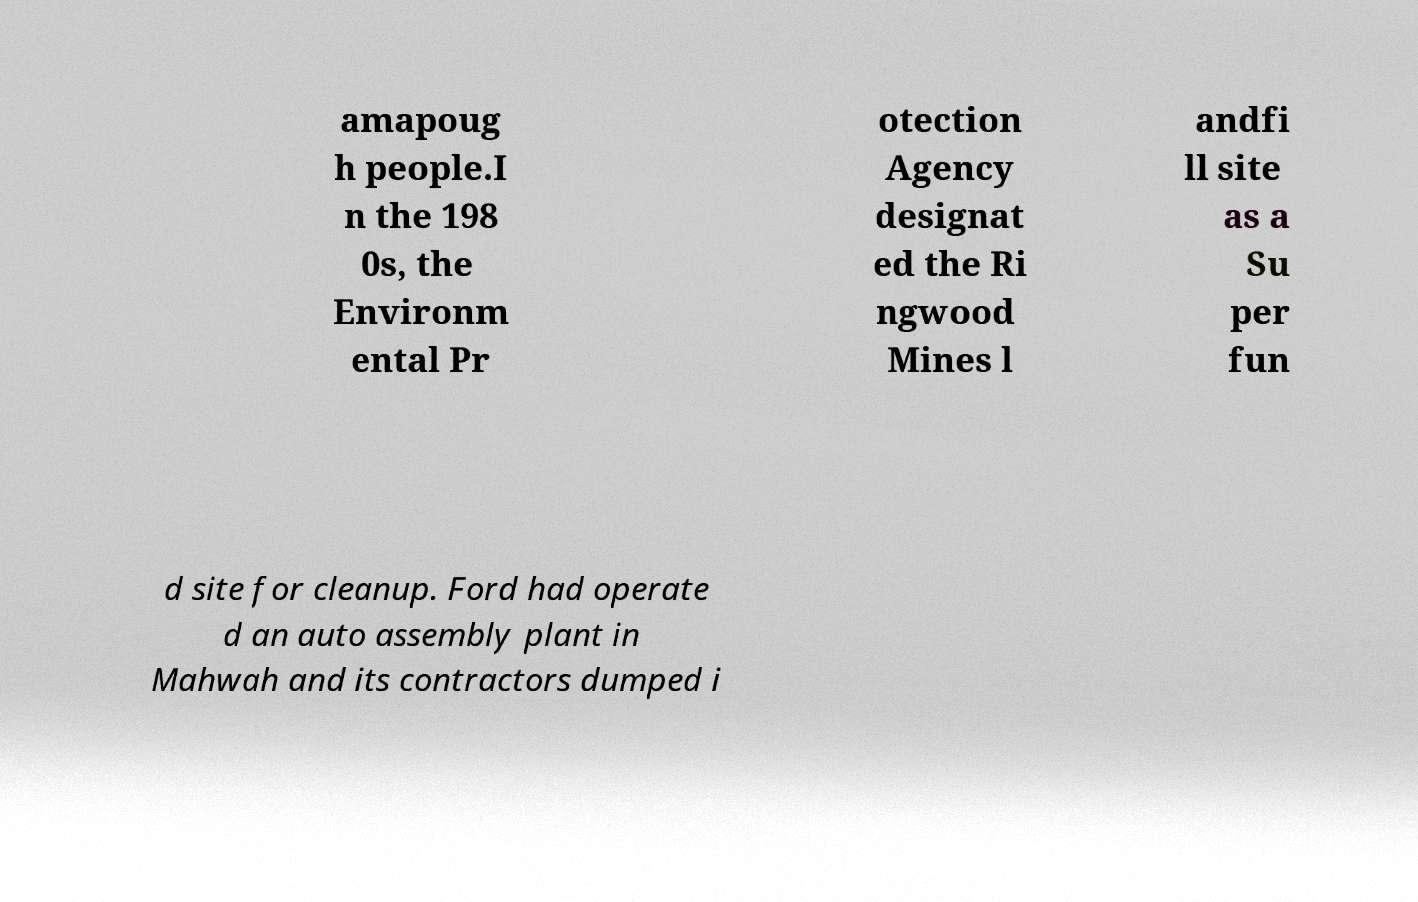Can you read and provide the text displayed in the image?This photo seems to have some interesting text. Can you extract and type it out for me? amapoug h people.I n the 198 0s, the Environm ental Pr otection Agency designat ed the Ri ngwood Mines l andfi ll site as a Su per fun d site for cleanup. Ford had operate d an auto assembly plant in Mahwah and its contractors dumped i 